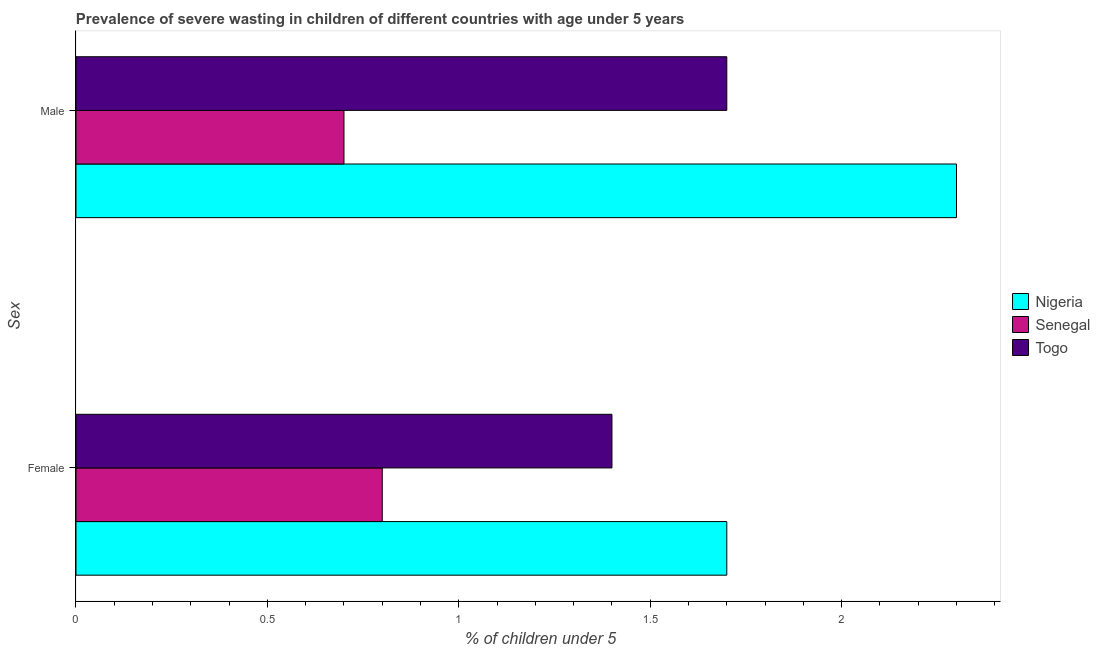How many different coloured bars are there?
Provide a succinct answer. 3. How many bars are there on the 1st tick from the top?
Make the answer very short. 3. How many bars are there on the 1st tick from the bottom?
Offer a terse response. 3. What is the label of the 1st group of bars from the top?
Provide a short and direct response. Male. What is the percentage of undernourished male children in Senegal?
Offer a very short reply. 0.7. Across all countries, what is the maximum percentage of undernourished female children?
Offer a very short reply. 1.7. Across all countries, what is the minimum percentage of undernourished female children?
Offer a terse response. 0.8. In which country was the percentage of undernourished female children maximum?
Your response must be concise. Nigeria. In which country was the percentage of undernourished male children minimum?
Provide a short and direct response. Senegal. What is the total percentage of undernourished male children in the graph?
Offer a very short reply. 4.7. What is the difference between the percentage of undernourished male children in Senegal and that in Togo?
Your answer should be compact. -1. What is the difference between the percentage of undernourished male children in Senegal and the percentage of undernourished female children in Nigeria?
Keep it short and to the point. -1. What is the average percentage of undernourished male children per country?
Offer a very short reply. 1.57. What is the difference between the percentage of undernourished male children and percentage of undernourished female children in Togo?
Give a very brief answer. 0.3. In how many countries, is the percentage of undernourished male children greater than 0.8 %?
Provide a succinct answer. 2. What is the ratio of the percentage of undernourished male children in Nigeria to that in Senegal?
Keep it short and to the point. 3.29. What does the 2nd bar from the top in Female represents?
Provide a succinct answer. Senegal. What does the 2nd bar from the bottom in Female represents?
Ensure brevity in your answer.  Senegal. How many bars are there?
Make the answer very short. 6. What is the difference between two consecutive major ticks on the X-axis?
Offer a very short reply. 0.5. Does the graph contain any zero values?
Provide a short and direct response. No. Does the graph contain grids?
Make the answer very short. No. How many legend labels are there?
Your response must be concise. 3. How are the legend labels stacked?
Your answer should be compact. Vertical. What is the title of the graph?
Your answer should be compact. Prevalence of severe wasting in children of different countries with age under 5 years. What is the label or title of the X-axis?
Provide a succinct answer.  % of children under 5. What is the label or title of the Y-axis?
Your answer should be very brief. Sex. What is the  % of children under 5 of Nigeria in Female?
Provide a succinct answer. 1.7. What is the  % of children under 5 in Senegal in Female?
Offer a terse response. 0.8. What is the  % of children under 5 in Togo in Female?
Offer a terse response. 1.4. What is the  % of children under 5 of Nigeria in Male?
Offer a terse response. 2.3. What is the  % of children under 5 of Senegal in Male?
Your response must be concise. 0.7. What is the  % of children under 5 in Togo in Male?
Provide a short and direct response. 1.7. Across all Sex, what is the maximum  % of children under 5 in Nigeria?
Keep it short and to the point. 2.3. Across all Sex, what is the maximum  % of children under 5 in Senegal?
Ensure brevity in your answer.  0.8. Across all Sex, what is the maximum  % of children under 5 of Togo?
Your answer should be very brief. 1.7. Across all Sex, what is the minimum  % of children under 5 in Nigeria?
Provide a short and direct response. 1.7. Across all Sex, what is the minimum  % of children under 5 in Senegal?
Make the answer very short. 0.7. Across all Sex, what is the minimum  % of children under 5 of Togo?
Give a very brief answer. 1.4. What is the total  % of children under 5 in Togo in the graph?
Keep it short and to the point. 3.1. What is the difference between the  % of children under 5 of Nigeria in Female and the  % of children under 5 of Senegal in Male?
Offer a very short reply. 1. What is the difference between the  % of children under 5 of Senegal in Female and the  % of children under 5 of Togo in Male?
Your answer should be very brief. -0.9. What is the average  % of children under 5 of Togo per Sex?
Offer a terse response. 1.55. What is the difference between the  % of children under 5 of Senegal and  % of children under 5 of Togo in Female?
Give a very brief answer. -0.6. What is the difference between the  % of children under 5 in Nigeria and  % of children under 5 in Senegal in Male?
Ensure brevity in your answer.  1.6. What is the ratio of the  % of children under 5 of Nigeria in Female to that in Male?
Ensure brevity in your answer.  0.74. What is the ratio of the  % of children under 5 in Senegal in Female to that in Male?
Provide a succinct answer. 1.14. What is the ratio of the  % of children under 5 in Togo in Female to that in Male?
Your answer should be very brief. 0.82. What is the difference between the highest and the second highest  % of children under 5 in Senegal?
Offer a terse response. 0.1. What is the difference between the highest and the second highest  % of children under 5 in Togo?
Your answer should be compact. 0.3. What is the difference between the highest and the lowest  % of children under 5 in Senegal?
Your answer should be very brief. 0.1. What is the difference between the highest and the lowest  % of children under 5 of Togo?
Provide a short and direct response. 0.3. 